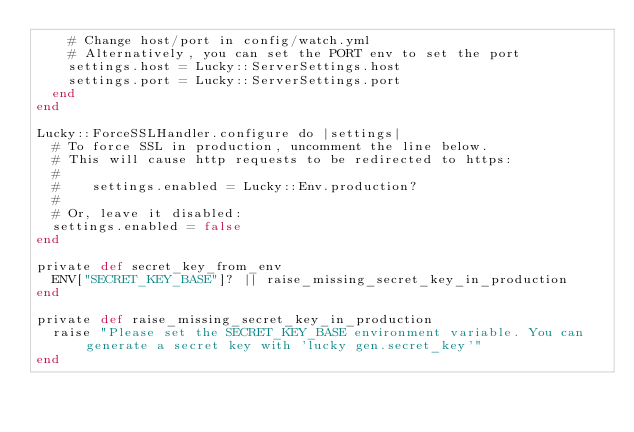Convert code to text. <code><loc_0><loc_0><loc_500><loc_500><_Crystal_>    # Change host/port in config/watch.yml
    # Alternatively, you can set the PORT env to set the port
    settings.host = Lucky::ServerSettings.host
    settings.port = Lucky::ServerSettings.port
  end
end

Lucky::ForceSSLHandler.configure do |settings|
  # To force SSL in production, uncomment the line below.
  # This will cause http requests to be redirected to https:
  #
  #    settings.enabled = Lucky::Env.production?
  #
  # Or, leave it disabled:
  settings.enabled = false
end

private def secret_key_from_env
  ENV["SECRET_KEY_BASE"]? || raise_missing_secret_key_in_production
end

private def raise_missing_secret_key_in_production
  raise "Please set the SECRET_KEY_BASE environment variable. You can generate a secret key with 'lucky gen.secret_key'"
end
</code> 